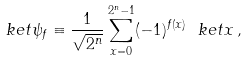<formula> <loc_0><loc_0><loc_500><loc_500>\ k e t { \psi _ { f } } \equiv \frac { 1 } { \sqrt { 2 ^ { n } } } \sum _ { x = 0 } ^ { 2 ^ { n } - 1 } ( - 1 ) ^ { f ( x ) } \ k e t { x } \, ,</formula> 